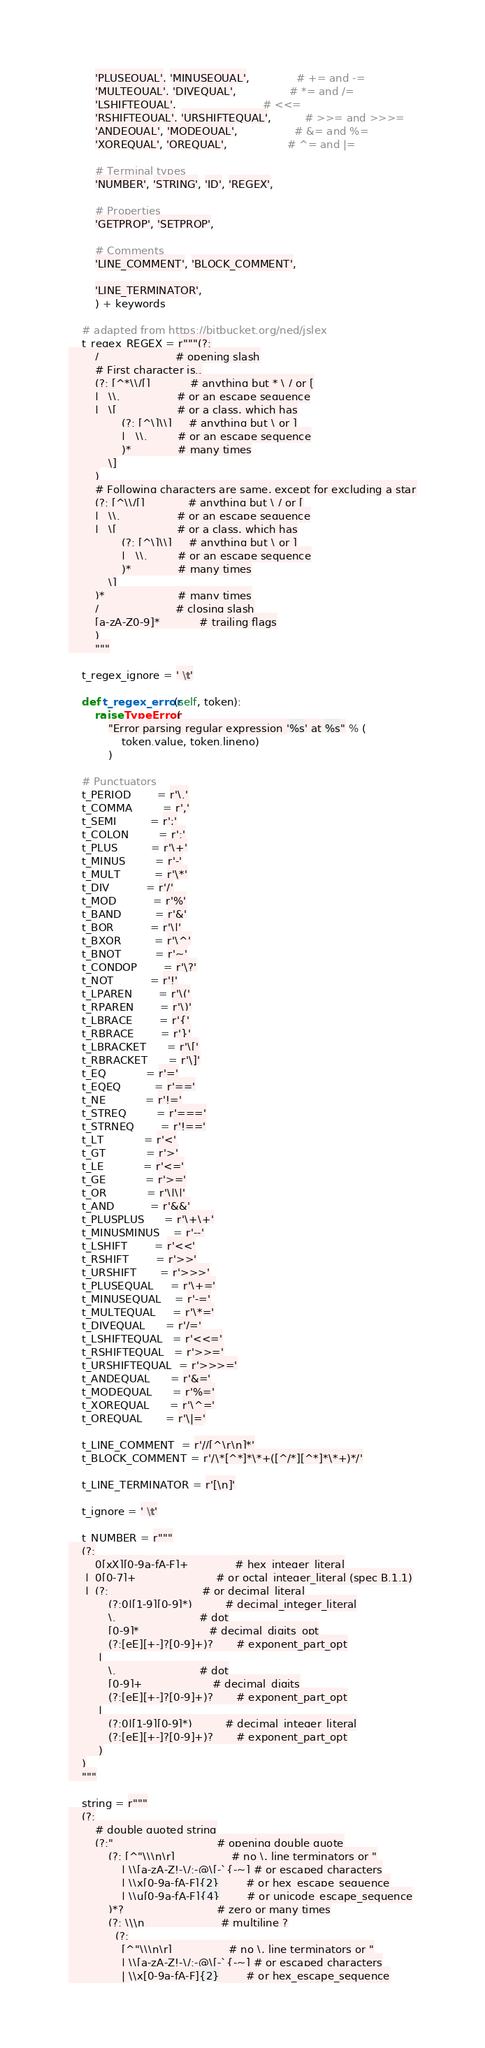Convert code to text. <code><loc_0><loc_0><loc_500><loc_500><_Python_>        'PLUSEQUAL', 'MINUSEQUAL',              # += and -=
        'MULTEQUAL', 'DIVEQUAL',                # *= and /=
        'LSHIFTEQUAL',                          # <<=
        'RSHIFTEQUAL', 'URSHIFTEQUAL',          # >>= and >>>=
        'ANDEQUAL', 'MODEQUAL',                 # &= and %=
        'XOREQUAL', 'OREQUAL',                  # ^= and |=

        # Terminal types
        'NUMBER', 'STRING', 'ID', 'REGEX',

        # Properties
        'GETPROP', 'SETPROP',

        # Comments
        'LINE_COMMENT', 'BLOCK_COMMENT',

        'LINE_TERMINATOR',
        ) + keywords

    # adapted from https://bitbucket.org/ned/jslex
    t_regex_REGEX = r"""(?:
        /                       # opening slash
        # First character is..
        (?: [^*\\/[]            # anything but * \ / or [
        |   \\.                 # or an escape sequence
        |   \[                  # or a class, which has
                (?: [^\]\\]     # anything but \ or ]
                |   \\.         # or an escape sequence
                )*              # many times
            \]
        )
        # Following characters are same, except for excluding a star
        (?: [^\\/[]             # anything but \ / or [
        |   \\.                 # or an escape sequence
        |   \[                  # or a class, which has
                (?: [^\]\\]     # anything but \ or ]
                |   \\.         # or an escape sequence
                )*              # many times
            \]
        )*                      # many times
        /                       # closing slash
        [a-zA-Z0-9]*            # trailing flags
        )
        """

    t_regex_ignore = ' \t'

    def t_regex_error(self, token):
        raise TypeError(
            "Error parsing regular expression '%s' at %s" % (
                token.value, token.lineno)
            )

    # Punctuators
    t_PERIOD        = r'\.'
    t_COMMA         = r','
    t_SEMI          = r';'
    t_COLON         = r':'
    t_PLUS          = r'\+'
    t_MINUS         = r'-'
    t_MULT          = r'\*'
    t_DIV           = r'/'
    t_MOD           = r'%'
    t_BAND          = r'&'
    t_BOR           = r'\|'
    t_BXOR          = r'\^'
    t_BNOT          = r'~'
    t_CONDOP        = r'\?'
    t_NOT           = r'!'
    t_LPAREN        = r'\('
    t_RPAREN        = r'\)'
    t_LBRACE        = r'{'
    t_RBRACE        = r'}'
    t_LBRACKET      = r'\['
    t_RBRACKET      = r'\]'
    t_EQ            = r'='
    t_EQEQ          = r'=='
    t_NE            = r'!='
    t_STREQ         = r'==='
    t_STRNEQ        = r'!=='
    t_LT            = r'<'
    t_GT            = r'>'
    t_LE            = r'<='
    t_GE            = r'>='
    t_OR            = r'\|\|'
    t_AND           = r'&&'
    t_PLUSPLUS      = r'\+\+'
    t_MINUSMINUS    = r'--'
    t_LSHIFT        = r'<<'
    t_RSHIFT        = r'>>'
    t_URSHIFT       = r'>>>'
    t_PLUSEQUAL     = r'\+='
    t_MINUSEQUAL    = r'-='
    t_MULTEQUAL     = r'\*='
    t_DIVEQUAL      = r'/='
    t_LSHIFTEQUAL   = r'<<='
    t_RSHIFTEQUAL   = r'>>='
    t_URSHIFTEQUAL  = r'>>>='
    t_ANDEQUAL      = r'&='
    t_MODEQUAL      = r'%='
    t_XOREQUAL      = r'\^='
    t_OREQUAL       = r'\|='

    t_LINE_COMMENT  = r'//[^\r\n]*'
    t_BLOCK_COMMENT = r'/\*[^*]*\*+([^/*][^*]*\*+)*/'

    t_LINE_TERMINATOR = r'[\n]'

    t_ignore = ' \t'

    t_NUMBER = r"""
    (?:
        0[xX][0-9a-fA-F]+              # hex_integer_literal
     |  0[0-7]+                        # or octal_integer_literal (spec B.1.1)
     |  (?:                            # or decimal_literal
            (?:0|[1-9][0-9]*)          # decimal_integer_literal
            \.                         # dot
            [0-9]*                     # decimal_digits_opt
            (?:[eE][+-]?[0-9]+)?       # exponent_part_opt
         |
            \.                         # dot
            [0-9]+                     # decimal_digits
            (?:[eE][+-]?[0-9]+)?       # exponent_part_opt
         |
            (?:0|[1-9][0-9]*)          # decimal_integer_literal
            (?:[eE][+-]?[0-9]+)?       # exponent_part_opt
         )
    )
    """

    string = r"""
    (?:
        # double quoted string
        (?:"                               # opening double quote
            (?: [^"\\\n\r]                 # no \, line terminators or "
                | \\[a-zA-Z!-\/:-@\[-`{-~] # or escaped characters
                | \\x[0-9a-fA-F]{2}        # or hex_escape_sequence
                | \\u[0-9a-fA-F]{4}        # or unicode_escape_sequence
            )*?                            # zero or many times
            (?: \\\n                       # multiline ?
              (?:
                [^"\\\n\r]                 # no \, line terminators or "
                | \\[a-zA-Z!-\/:-@\[-`{-~] # or escaped characters
                | \\x[0-9a-fA-F]{2}        # or hex_escape_sequence</code> 